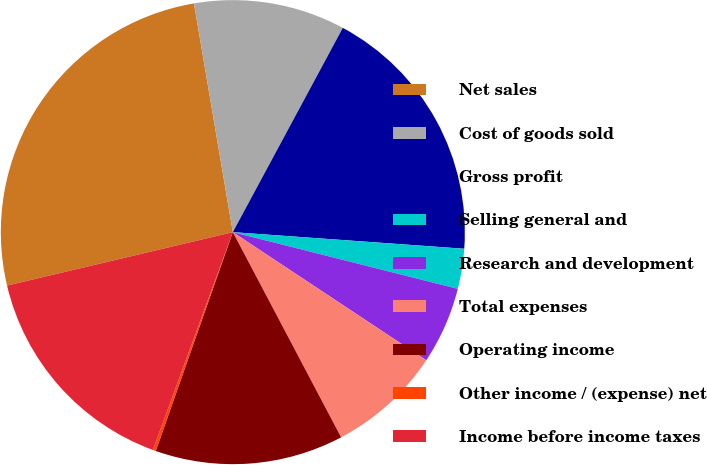Convert chart. <chart><loc_0><loc_0><loc_500><loc_500><pie_chart><fcel>Net sales<fcel>Cost of goods sold<fcel>Gross profit<fcel>Selling general and<fcel>Research and development<fcel>Total expenses<fcel>Operating income<fcel>Other income / (expense) net<fcel>Income before income taxes<nl><fcel>26.02%<fcel>10.54%<fcel>18.28%<fcel>2.79%<fcel>5.38%<fcel>7.96%<fcel>13.12%<fcel>0.21%<fcel>15.7%<nl></chart> 